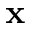<formula> <loc_0><loc_0><loc_500><loc_500>x</formula> 